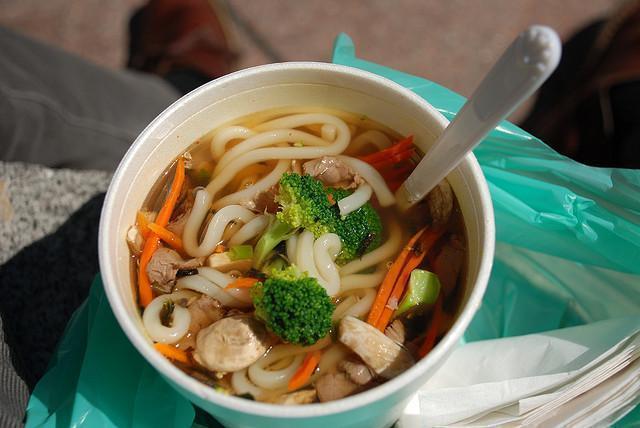What country do the noodles originate from?
Pick the right solution, then justify: 'Answer: answer
Rationale: rationale.'
Options: Ukraine, korea, japan, china. Answer: china.
Rationale: Noodles come from china. 